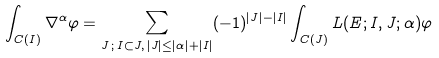Convert formula to latex. <formula><loc_0><loc_0><loc_500><loc_500>\int _ { C ( I ) } \nabla ^ { \alpha } \varphi = \sum _ { J \, ; \, I \subset J , \, | J | \leq | \alpha | + | I | } ( - 1 ) ^ { | J | - | I | } \int _ { C ( J ) } L ( E ; I , J ; \alpha ) \varphi</formula> 